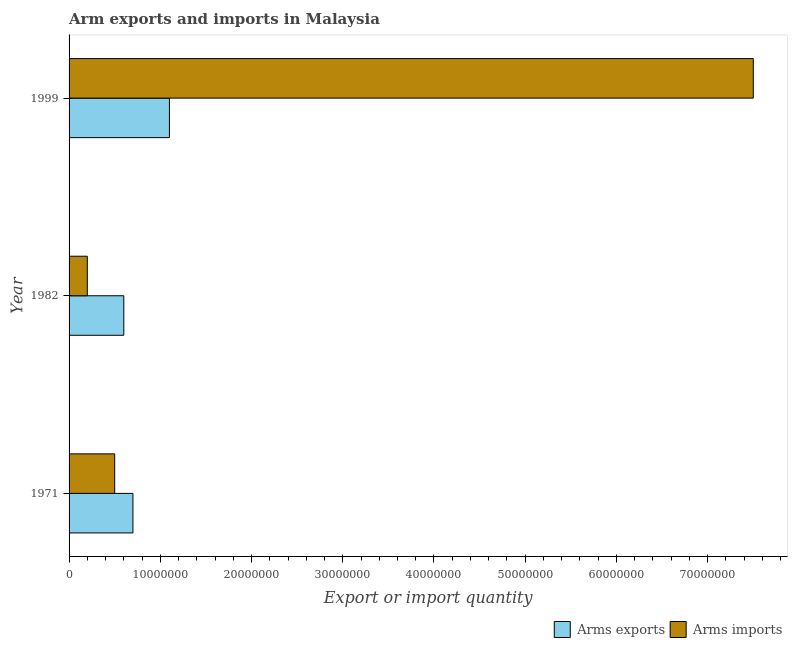How many different coloured bars are there?
Give a very brief answer. 2. How many groups of bars are there?
Keep it short and to the point. 3. Are the number of bars per tick equal to the number of legend labels?
Keep it short and to the point. Yes. How many bars are there on the 3rd tick from the bottom?
Ensure brevity in your answer.  2. In how many cases, is the number of bars for a given year not equal to the number of legend labels?
Your response must be concise. 0. What is the arms exports in 1971?
Make the answer very short. 7.00e+06. Across all years, what is the maximum arms exports?
Provide a succinct answer. 1.10e+07. Across all years, what is the minimum arms imports?
Provide a short and direct response. 2.00e+06. What is the total arms imports in the graph?
Your response must be concise. 8.20e+07. What is the difference between the arms exports in 1982 and that in 1999?
Your answer should be very brief. -5.00e+06. What is the difference between the arms exports in 1971 and the arms imports in 1999?
Provide a short and direct response. -6.80e+07. What is the average arms exports per year?
Provide a succinct answer. 8.00e+06. In the year 1999, what is the difference between the arms exports and arms imports?
Offer a very short reply. -6.40e+07. In how many years, is the arms imports greater than 76000000 ?
Your answer should be very brief. 0. What is the ratio of the arms exports in 1971 to that in 1982?
Provide a short and direct response. 1.17. Is the arms exports in 1982 less than that in 1999?
Offer a very short reply. Yes. What is the difference between the highest and the second highest arms imports?
Your response must be concise. 7.00e+07. What is the difference between the highest and the lowest arms exports?
Make the answer very short. 5.00e+06. Is the sum of the arms exports in 1982 and 1999 greater than the maximum arms imports across all years?
Give a very brief answer. No. What does the 2nd bar from the top in 1999 represents?
Provide a short and direct response. Arms exports. What does the 1st bar from the bottom in 1982 represents?
Your answer should be very brief. Arms exports. How many bars are there?
Your answer should be very brief. 6. Are all the bars in the graph horizontal?
Offer a terse response. Yes. How many years are there in the graph?
Ensure brevity in your answer.  3. How many legend labels are there?
Ensure brevity in your answer.  2. How are the legend labels stacked?
Offer a terse response. Horizontal. What is the title of the graph?
Keep it short and to the point. Arm exports and imports in Malaysia. Does "IMF nonconcessional" appear as one of the legend labels in the graph?
Ensure brevity in your answer.  No. What is the label or title of the X-axis?
Offer a terse response. Export or import quantity. What is the Export or import quantity of Arms imports in 1982?
Ensure brevity in your answer.  2.00e+06. What is the Export or import quantity of Arms exports in 1999?
Offer a terse response. 1.10e+07. What is the Export or import quantity of Arms imports in 1999?
Your answer should be very brief. 7.50e+07. Across all years, what is the maximum Export or import quantity of Arms exports?
Provide a short and direct response. 1.10e+07. Across all years, what is the maximum Export or import quantity in Arms imports?
Ensure brevity in your answer.  7.50e+07. Across all years, what is the minimum Export or import quantity of Arms exports?
Your response must be concise. 6.00e+06. Across all years, what is the minimum Export or import quantity in Arms imports?
Provide a short and direct response. 2.00e+06. What is the total Export or import quantity of Arms exports in the graph?
Provide a succinct answer. 2.40e+07. What is the total Export or import quantity of Arms imports in the graph?
Ensure brevity in your answer.  8.20e+07. What is the difference between the Export or import quantity of Arms exports in 1971 and that in 1982?
Your answer should be very brief. 1.00e+06. What is the difference between the Export or import quantity of Arms imports in 1971 and that in 1982?
Keep it short and to the point. 3.00e+06. What is the difference between the Export or import quantity of Arms imports in 1971 and that in 1999?
Make the answer very short. -7.00e+07. What is the difference between the Export or import quantity in Arms exports in 1982 and that in 1999?
Make the answer very short. -5.00e+06. What is the difference between the Export or import quantity of Arms imports in 1982 and that in 1999?
Provide a succinct answer. -7.30e+07. What is the difference between the Export or import quantity in Arms exports in 1971 and the Export or import quantity in Arms imports in 1999?
Your response must be concise. -6.80e+07. What is the difference between the Export or import quantity in Arms exports in 1982 and the Export or import quantity in Arms imports in 1999?
Provide a succinct answer. -6.90e+07. What is the average Export or import quantity in Arms exports per year?
Offer a terse response. 8.00e+06. What is the average Export or import quantity in Arms imports per year?
Provide a short and direct response. 2.73e+07. In the year 1999, what is the difference between the Export or import quantity in Arms exports and Export or import quantity in Arms imports?
Keep it short and to the point. -6.40e+07. What is the ratio of the Export or import quantity of Arms exports in 1971 to that in 1999?
Ensure brevity in your answer.  0.64. What is the ratio of the Export or import quantity in Arms imports in 1971 to that in 1999?
Provide a short and direct response. 0.07. What is the ratio of the Export or import quantity in Arms exports in 1982 to that in 1999?
Your answer should be compact. 0.55. What is the ratio of the Export or import quantity in Arms imports in 1982 to that in 1999?
Your answer should be very brief. 0.03. What is the difference between the highest and the second highest Export or import quantity of Arms exports?
Provide a short and direct response. 4.00e+06. What is the difference between the highest and the second highest Export or import quantity in Arms imports?
Make the answer very short. 7.00e+07. What is the difference between the highest and the lowest Export or import quantity in Arms exports?
Offer a very short reply. 5.00e+06. What is the difference between the highest and the lowest Export or import quantity of Arms imports?
Give a very brief answer. 7.30e+07. 